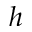Convert formula to latex. <formula><loc_0><loc_0><loc_500><loc_500>h</formula> 